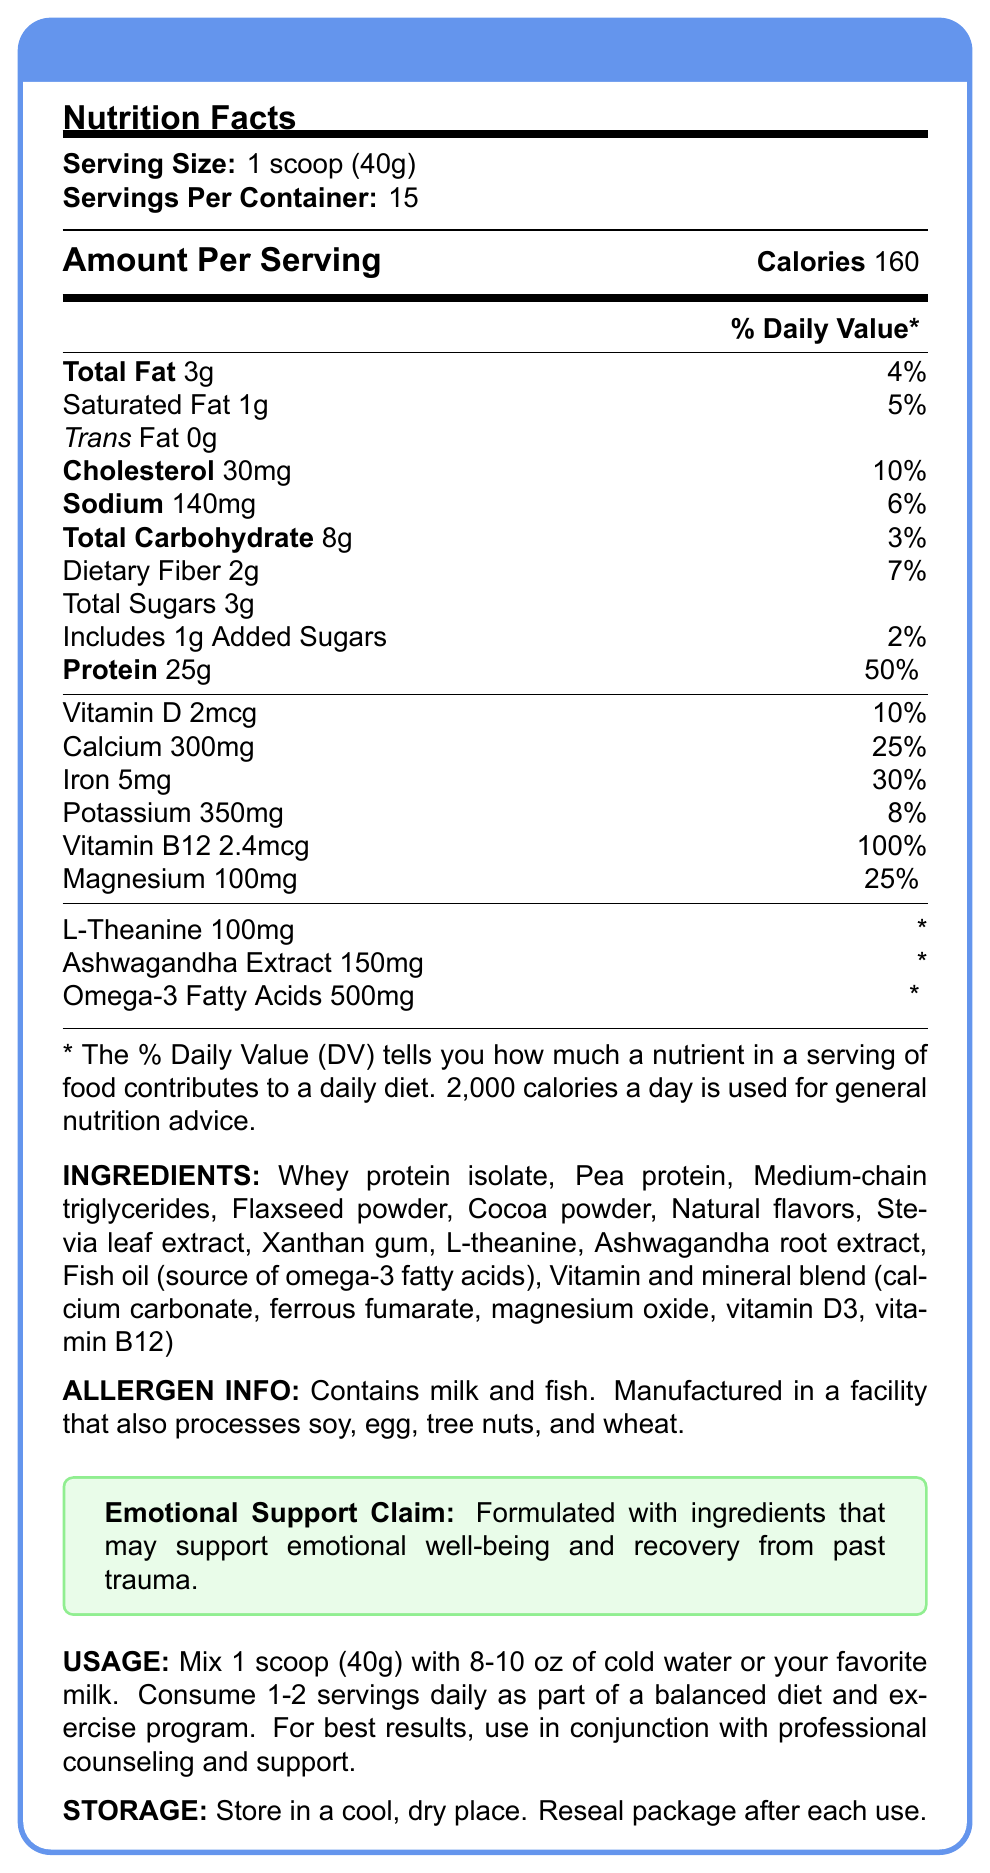what is the serving size of the Emotional Recovery Protein Shake? The serving size is prominently displayed on the nutrition facts label as "1 scoop (40g)".
Answer: 1 scoop (40g) how many calories are there per serving? The document states "Calories 160" in the Amount Per Serving section.
Answer: 160 what percentage of the daily value for protein does one serving provide? The document indicates "Protein 25g \hfill 50%" under the Amount Per Serving section.
Answer: 50% how much cholesterol is in one serving? The nutrition facts state that there are "30mg" of cholesterol per serving.
Answer: 30mg how much calcium is in each serving? The document lists "Calcium 300mg \hfill 25%" under the mineral content.
Answer: 300mg how many servings are there per container? The document specifies "Servings Per Container: 15".
Answer: 15 which of the following ingredients are included in the protein shake? A. Whey protein isolate B. Cocoa butter C. Coconut oil D. Spirulina "Whey protein isolate" is listed in the ingredients section but cocoa butter, coconut oil, and spirulina are not.
Answer: A What is the daily value percentage for iron in each serving? A. 10% B. 25% C. 30% D. 50% The document lists "Iron 5mg \hfill 30%" under the vitamins and minerals section.
Answer: C True or False: The Emotional Recovery Protein Shake contains ashwagandha extract. "Ashwagandha root extract" is listed in the ingredients.
Answer: True Summarize the main purpose of the Emotional Recovery Protein Shake. The document specifies the shake's nutritional profile, including protein, vitamins, and specialized ingredients meant to support emotional health. It also provides usage, storage instructions, and allergen information.
Answer: The Emotional Recovery Protein Shake is designed to provide high protein content for nutritional support, with additional ingredients like L-theanine and ashwagandha that may help emotional well-being and recovery from past trauma. How many grams of saturated fat are in one serving? The nutrition facts indicate "Saturated Fat 1g \hfill 5%" in the Amount Per Serving section.
Answer: 1g Is the product allergen-free? The allergen information states it contains milk and fish and is manufactured in a facility that also processes soy, egg, tree nuts, and wheat.
Answer: No Can the amount of Omega-3 Fatty Acids in the shake be determined as a percentage of daily value? The document lists "Omega-3 Fatty Acids 500mg" but does not provide a daily value percentage for comparison.
Answer: Not enough information 